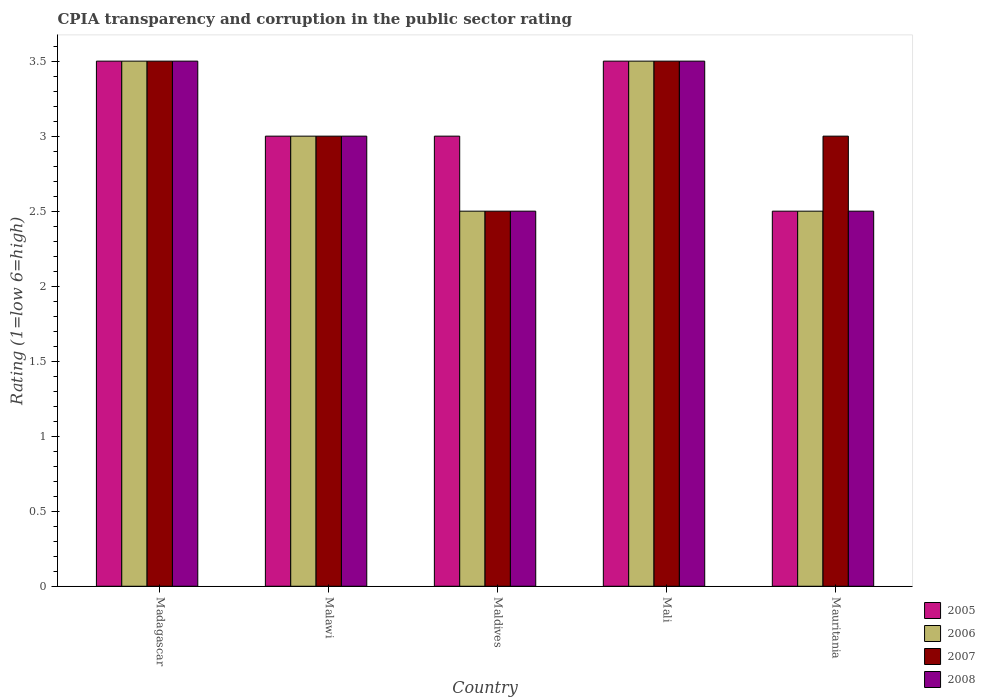How many different coloured bars are there?
Offer a terse response. 4. How many groups of bars are there?
Provide a succinct answer. 5. Are the number of bars per tick equal to the number of legend labels?
Offer a terse response. Yes. How many bars are there on the 5th tick from the left?
Your answer should be very brief. 4. How many bars are there on the 2nd tick from the right?
Offer a terse response. 4. What is the label of the 4th group of bars from the left?
Keep it short and to the point. Mali. Across all countries, what is the maximum CPIA rating in 2007?
Keep it short and to the point. 3.5. Across all countries, what is the minimum CPIA rating in 2008?
Your answer should be very brief. 2.5. In which country was the CPIA rating in 2007 maximum?
Give a very brief answer. Madagascar. In which country was the CPIA rating in 2007 minimum?
Your response must be concise. Maldives. What is the difference between the CPIA rating in 2005 in Madagascar and that in Maldives?
Ensure brevity in your answer.  0.5. What is the difference between the CPIA rating of/in 2006 and CPIA rating of/in 2008 in Mali?
Provide a short and direct response. 0. In how many countries, is the CPIA rating in 2005 greater than 0.30000000000000004?
Provide a short and direct response. 5. What is the ratio of the CPIA rating in 2008 in Malawi to that in Mali?
Offer a very short reply. 0.86. What is the difference between the highest and the second highest CPIA rating in 2005?
Ensure brevity in your answer.  -0.5. What is the difference between the highest and the lowest CPIA rating in 2008?
Ensure brevity in your answer.  1. In how many countries, is the CPIA rating in 2007 greater than the average CPIA rating in 2007 taken over all countries?
Give a very brief answer. 2. Is the sum of the CPIA rating in 2008 in Madagascar and Maldives greater than the maximum CPIA rating in 2005 across all countries?
Provide a short and direct response. Yes. What does the 3rd bar from the left in Mali represents?
Provide a short and direct response. 2007. What does the 3rd bar from the right in Maldives represents?
Provide a succinct answer. 2006. Are all the bars in the graph horizontal?
Your response must be concise. No. How many countries are there in the graph?
Provide a succinct answer. 5. What is the difference between two consecutive major ticks on the Y-axis?
Make the answer very short. 0.5. Are the values on the major ticks of Y-axis written in scientific E-notation?
Offer a terse response. No. Does the graph contain any zero values?
Offer a very short reply. No. How many legend labels are there?
Your answer should be very brief. 4. How are the legend labels stacked?
Offer a very short reply. Vertical. What is the title of the graph?
Offer a terse response. CPIA transparency and corruption in the public sector rating. What is the label or title of the X-axis?
Make the answer very short. Country. What is the label or title of the Y-axis?
Your response must be concise. Rating (1=low 6=high). What is the Rating (1=low 6=high) of 2006 in Madagascar?
Make the answer very short. 3.5. What is the Rating (1=low 6=high) of 2007 in Madagascar?
Provide a succinct answer. 3.5. What is the Rating (1=low 6=high) of 2006 in Malawi?
Your answer should be compact. 3. What is the Rating (1=low 6=high) in 2008 in Malawi?
Provide a short and direct response. 3. What is the Rating (1=low 6=high) of 2005 in Maldives?
Provide a short and direct response. 3. What is the Rating (1=low 6=high) in 2005 in Mali?
Offer a terse response. 3.5. What is the Rating (1=low 6=high) in 2006 in Mali?
Offer a terse response. 3.5. Across all countries, what is the maximum Rating (1=low 6=high) in 2005?
Provide a short and direct response. 3.5. Across all countries, what is the maximum Rating (1=low 6=high) in 2007?
Keep it short and to the point. 3.5. Across all countries, what is the maximum Rating (1=low 6=high) of 2008?
Provide a short and direct response. 3.5. Across all countries, what is the minimum Rating (1=low 6=high) in 2005?
Give a very brief answer. 2.5. Across all countries, what is the minimum Rating (1=low 6=high) of 2006?
Offer a terse response. 2.5. What is the total Rating (1=low 6=high) of 2008 in the graph?
Your response must be concise. 15. What is the difference between the Rating (1=low 6=high) of 2005 in Madagascar and that in Malawi?
Provide a succinct answer. 0.5. What is the difference between the Rating (1=low 6=high) of 2006 in Madagascar and that in Malawi?
Your response must be concise. 0.5. What is the difference between the Rating (1=low 6=high) in 2008 in Madagascar and that in Malawi?
Your answer should be compact. 0.5. What is the difference between the Rating (1=low 6=high) of 2005 in Madagascar and that in Maldives?
Keep it short and to the point. 0.5. What is the difference between the Rating (1=low 6=high) of 2006 in Madagascar and that in Maldives?
Offer a very short reply. 1. What is the difference between the Rating (1=low 6=high) in 2008 in Madagascar and that in Maldives?
Your response must be concise. 1. What is the difference between the Rating (1=low 6=high) of 2007 in Madagascar and that in Mali?
Give a very brief answer. 0. What is the difference between the Rating (1=low 6=high) in 2005 in Madagascar and that in Mauritania?
Offer a very short reply. 1. What is the difference between the Rating (1=low 6=high) of 2006 in Madagascar and that in Mauritania?
Your response must be concise. 1. What is the difference between the Rating (1=low 6=high) in 2008 in Madagascar and that in Mauritania?
Offer a very short reply. 1. What is the difference between the Rating (1=low 6=high) in 2006 in Malawi and that in Maldives?
Ensure brevity in your answer.  0.5. What is the difference between the Rating (1=low 6=high) in 2007 in Malawi and that in Maldives?
Give a very brief answer. 0.5. What is the difference between the Rating (1=low 6=high) in 2005 in Malawi and that in Mali?
Your answer should be compact. -0.5. What is the difference between the Rating (1=low 6=high) in 2007 in Malawi and that in Mali?
Your answer should be very brief. -0.5. What is the difference between the Rating (1=low 6=high) of 2008 in Malawi and that in Mali?
Give a very brief answer. -0.5. What is the difference between the Rating (1=low 6=high) of 2006 in Maldives and that in Mali?
Your response must be concise. -1. What is the difference between the Rating (1=low 6=high) of 2008 in Maldives and that in Mali?
Keep it short and to the point. -1. What is the difference between the Rating (1=low 6=high) of 2006 in Maldives and that in Mauritania?
Offer a terse response. 0. What is the difference between the Rating (1=low 6=high) of 2005 in Mali and that in Mauritania?
Provide a succinct answer. 1. What is the difference between the Rating (1=low 6=high) in 2008 in Mali and that in Mauritania?
Give a very brief answer. 1. What is the difference between the Rating (1=low 6=high) in 2005 in Madagascar and the Rating (1=low 6=high) in 2007 in Malawi?
Provide a succinct answer. 0.5. What is the difference between the Rating (1=low 6=high) in 2007 in Madagascar and the Rating (1=low 6=high) in 2008 in Malawi?
Make the answer very short. 0.5. What is the difference between the Rating (1=low 6=high) in 2005 in Madagascar and the Rating (1=low 6=high) in 2008 in Maldives?
Your answer should be very brief. 1. What is the difference between the Rating (1=low 6=high) of 2005 in Madagascar and the Rating (1=low 6=high) of 2006 in Mali?
Ensure brevity in your answer.  0. What is the difference between the Rating (1=low 6=high) in 2005 in Madagascar and the Rating (1=low 6=high) in 2007 in Mali?
Give a very brief answer. 0. What is the difference between the Rating (1=low 6=high) in 2005 in Madagascar and the Rating (1=low 6=high) in 2008 in Mali?
Your response must be concise. 0. What is the difference between the Rating (1=low 6=high) of 2005 in Madagascar and the Rating (1=low 6=high) of 2006 in Mauritania?
Ensure brevity in your answer.  1. What is the difference between the Rating (1=low 6=high) in 2005 in Madagascar and the Rating (1=low 6=high) in 2007 in Mauritania?
Your answer should be compact. 0.5. What is the difference between the Rating (1=low 6=high) of 2006 in Madagascar and the Rating (1=low 6=high) of 2007 in Mauritania?
Give a very brief answer. 0.5. What is the difference between the Rating (1=low 6=high) of 2006 in Madagascar and the Rating (1=low 6=high) of 2008 in Mauritania?
Offer a very short reply. 1. What is the difference between the Rating (1=low 6=high) in 2006 in Malawi and the Rating (1=low 6=high) in 2007 in Maldives?
Provide a short and direct response. 0.5. What is the difference between the Rating (1=low 6=high) of 2007 in Malawi and the Rating (1=low 6=high) of 2008 in Maldives?
Ensure brevity in your answer.  0.5. What is the difference between the Rating (1=low 6=high) in 2005 in Malawi and the Rating (1=low 6=high) in 2007 in Mali?
Your answer should be very brief. -0.5. What is the difference between the Rating (1=low 6=high) of 2005 in Malawi and the Rating (1=low 6=high) of 2008 in Mali?
Your answer should be very brief. -0.5. What is the difference between the Rating (1=low 6=high) of 2006 in Malawi and the Rating (1=low 6=high) of 2008 in Mali?
Offer a terse response. -0.5. What is the difference between the Rating (1=low 6=high) in 2007 in Malawi and the Rating (1=low 6=high) in 2008 in Mali?
Keep it short and to the point. -0.5. What is the difference between the Rating (1=low 6=high) of 2005 in Malawi and the Rating (1=low 6=high) of 2008 in Mauritania?
Keep it short and to the point. 0.5. What is the difference between the Rating (1=low 6=high) in 2006 in Malawi and the Rating (1=low 6=high) in 2007 in Mauritania?
Your response must be concise. 0. What is the difference between the Rating (1=low 6=high) of 2006 in Malawi and the Rating (1=low 6=high) of 2008 in Mauritania?
Your answer should be compact. 0.5. What is the difference between the Rating (1=low 6=high) of 2005 in Maldives and the Rating (1=low 6=high) of 2008 in Mali?
Provide a short and direct response. -0.5. What is the difference between the Rating (1=low 6=high) in 2006 in Maldives and the Rating (1=low 6=high) in 2008 in Mali?
Make the answer very short. -1. What is the difference between the Rating (1=low 6=high) of 2007 in Maldives and the Rating (1=low 6=high) of 2008 in Mali?
Offer a very short reply. -1. What is the difference between the Rating (1=low 6=high) of 2005 in Maldives and the Rating (1=low 6=high) of 2008 in Mauritania?
Your answer should be very brief. 0.5. What is the difference between the Rating (1=low 6=high) of 2005 in Mali and the Rating (1=low 6=high) of 2007 in Mauritania?
Provide a succinct answer. 0.5. What is the difference between the Rating (1=low 6=high) of 2005 in Mali and the Rating (1=low 6=high) of 2008 in Mauritania?
Your answer should be very brief. 1. What is the difference between the Rating (1=low 6=high) in 2006 in Mali and the Rating (1=low 6=high) in 2007 in Mauritania?
Your response must be concise. 0.5. What is the difference between the Rating (1=low 6=high) of 2007 in Mali and the Rating (1=low 6=high) of 2008 in Mauritania?
Provide a succinct answer. 1. What is the average Rating (1=low 6=high) in 2005 per country?
Ensure brevity in your answer.  3.1. What is the average Rating (1=low 6=high) of 2007 per country?
Your answer should be very brief. 3.1. What is the difference between the Rating (1=low 6=high) in 2005 and Rating (1=low 6=high) in 2007 in Madagascar?
Keep it short and to the point. 0. What is the difference between the Rating (1=low 6=high) of 2005 and Rating (1=low 6=high) of 2008 in Madagascar?
Offer a terse response. 0. What is the difference between the Rating (1=low 6=high) of 2006 and Rating (1=low 6=high) of 2007 in Madagascar?
Offer a very short reply. 0. What is the difference between the Rating (1=low 6=high) of 2006 and Rating (1=low 6=high) of 2008 in Madagascar?
Your answer should be compact. 0. What is the difference between the Rating (1=low 6=high) of 2006 and Rating (1=low 6=high) of 2007 in Malawi?
Offer a terse response. 0. What is the difference between the Rating (1=low 6=high) in 2006 and Rating (1=low 6=high) in 2008 in Malawi?
Provide a succinct answer. 0. What is the difference between the Rating (1=low 6=high) in 2005 and Rating (1=low 6=high) in 2006 in Maldives?
Give a very brief answer. 0.5. What is the difference between the Rating (1=low 6=high) of 2006 and Rating (1=low 6=high) of 2007 in Maldives?
Your answer should be very brief. 0. What is the difference between the Rating (1=low 6=high) in 2005 and Rating (1=low 6=high) in 2008 in Mali?
Ensure brevity in your answer.  0. What is the difference between the Rating (1=low 6=high) in 2006 and Rating (1=low 6=high) in 2007 in Mali?
Offer a terse response. 0. What is the difference between the Rating (1=low 6=high) in 2006 and Rating (1=low 6=high) in 2007 in Mauritania?
Your answer should be very brief. -0.5. What is the difference between the Rating (1=low 6=high) of 2007 and Rating (1=low 6=high) of 2008 in Mauritania?
Make the answer very short. 0.5. What is the ratio of the Rating (1=low 6=high) in 2005 in Madagascar to that in Malawi?
Make the answer very short. 1.17. What is the ratio of the Rating (1=low 6=high) of 2006 in Madagascar to that in Malawi?
Provide a short and direct response. 1.17. What is the ratio of the Rating (1=low 6=high) of 2007 in Madagascar to that in Malawi?
Give a very brief answer. 1.17. What is the ratio of the Rating (1=low 6=high) in 2007 in Madagascar to that in Maldives?
Give a very brief answer. 1.4. What is the ratio of the Rating (1=low 6=high) in 2008 in Madagascar to that in Maldives?
Your answer should be compact. 1.4. What is the ratio of the Rating (1=low 6=high) of 2005 in Madagascar to that in Mali?
Ensure brevity in your answer.  1. What is the ratio of the Rating (1=low 6=high) of 2006 in Madagascar to that in Mali?
Your answer should be compact. 1. What is the ratio of the Rating (1=low 6=high) in 2007 in Madagascar to that in Mali?
Offer a terse response. 1. What is the ratio of the Rating (1=low 6=high) of 2008 in Madagascar to that in Mali?
Your response must be concise. 1. What is the ratio of the Rating (1=low 6=high) of 2008 in Madagascar to that in Mauritania?
Provide a short and direct response. 1.4. What is the ratio of the Rating (1=low 6=high) of 2006 in Malawi to that in Maldives?
Your answer should be compact. 1.2. What is the ratio of the Rating (1=low 6=high) in 2006 in Malawi to that in Mali?
Give a very brief answer. 0.86. What is the ratio of the Rating (1=low 6=high) of 2008 in Malawi to that in Mali?
Your answer should be very brief. 0.86. What is the ratio of the Rating (1=low 6=high) of 2007 in Malawi to that in Mauritania?
Make the answer very short. 1. What is the ratio of the Rating (1=low 6=high) of 2008 in Malawi to that in Mauritania?
Ensure brevity in your answer.  1.2. What is the ratio of the Rating (1=low 6=high) of 2005 in Maldives to that in Mali?
Offer a terse response. 0.86. What is the ratio of the Rating (1=low 6=high) in 2007 in Maldives to that in Mali?
Provide a succinct answer. 0.71. What is the ratio of the Rating (1=low 6=high) of 2005 in Maldives to that in Mauritania?
Ensure brevity in your answer.  1.2. What is the ratio of the Rating (1=low 6=high) of 2008 in Maldives to that in Mauritania?
Keep it short and to the point. 1. What is the ratio of the Rating (1=low 6=high) of 2005 in Mali to that in Mauritania?
Your answer should be very brief. 1.4. What is the difference between the highest and the second highest Rating (1=low 6=high) in 2005?
Provide a short and direct response. 0. What is the difference between the highest and the second highest Rating (1=low 6=high) in 2006?
Your answer should be very brief. 0. What is the difference between the highest and the lowest Rating (1=low 6=high) in 2006?
Give a very brief answer. 1. What is the difference between the highest and the lowest Rating (1=low 6=high) of 2008?
Your answer should be compact. 1. 